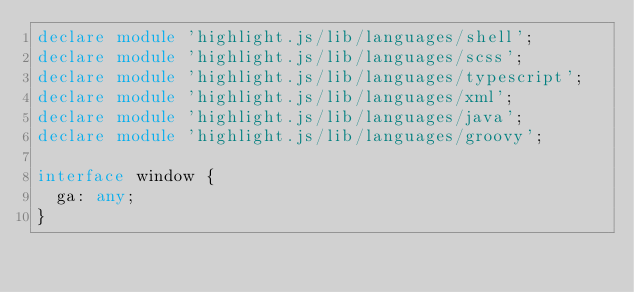<code> <loc_0><loc_0><loc_500><loc_500><_TypeScript_>declare module 'highlight.js/lib/languages/shell';
declare module 'highlight.js/lib/languages/scss';
declare module 'highlight.js/lib/languages/typescript';
declare module 'highlight.js/lib/languages/xml';
declare module 'highlight.js/lib/languages/java';
declare module 'highlight.js/lib/languages/groovy';

interface window {
  ga: any;
}
</code> 